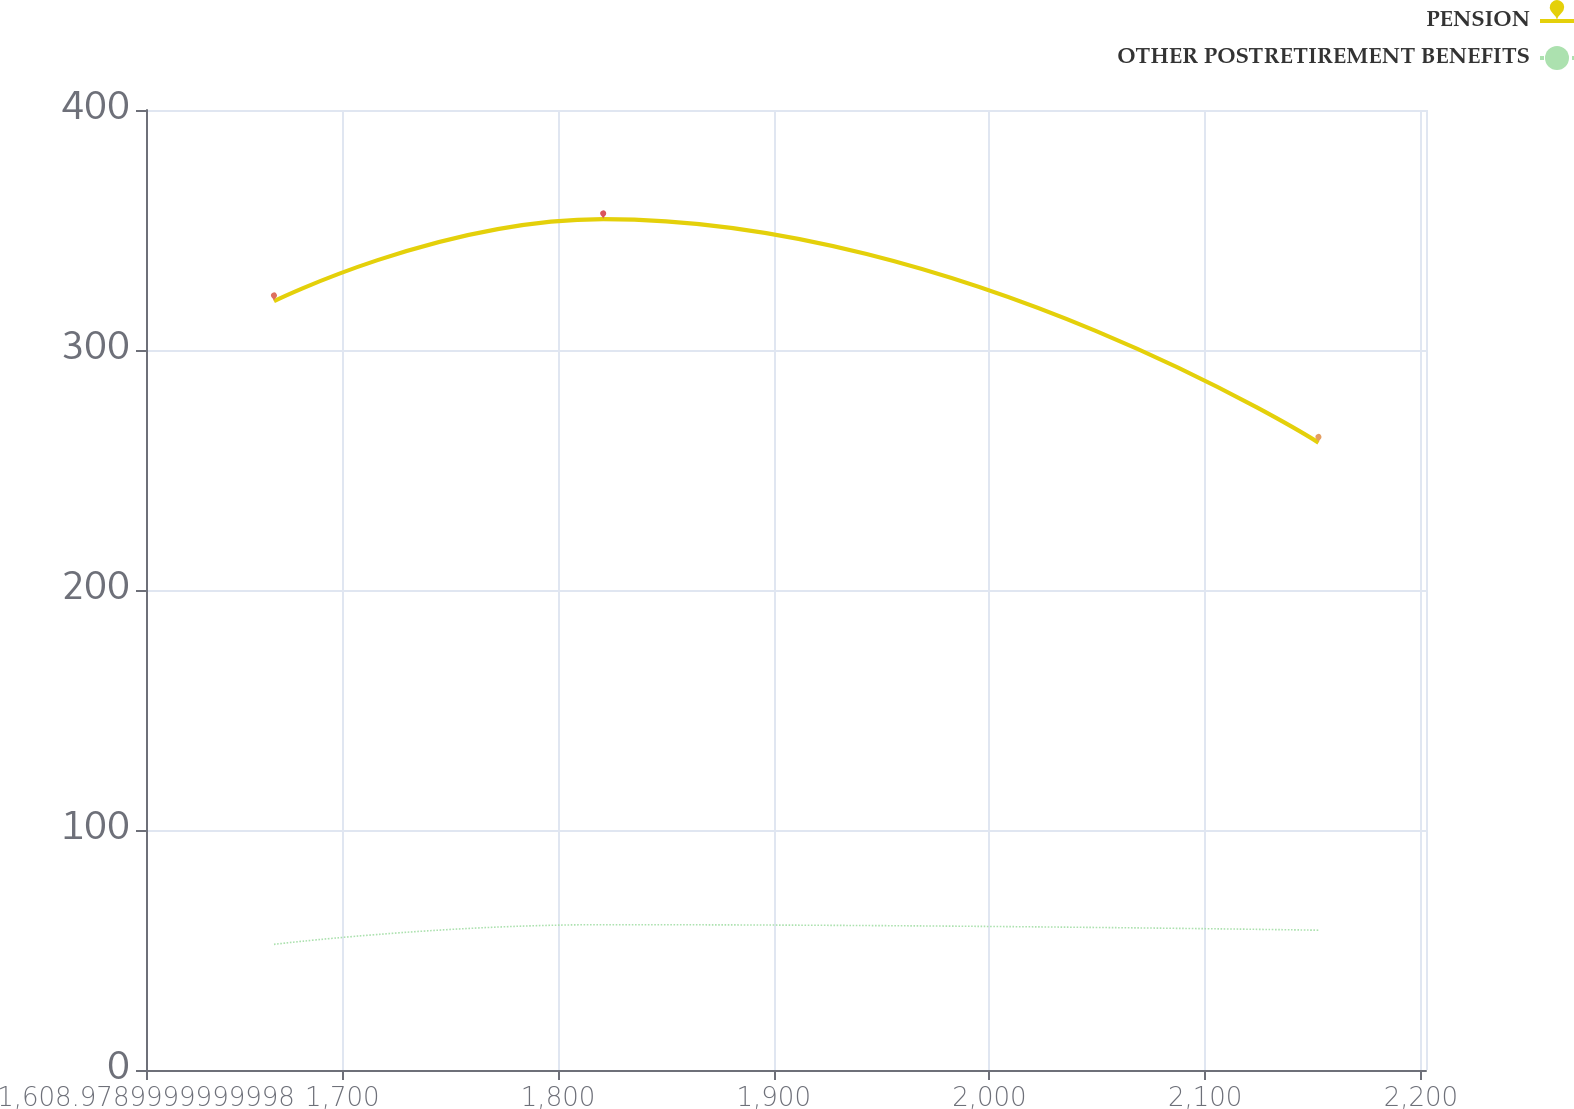<chart> <loc_0><loc_0><loc_500><loc_500><line_chart><ecel><fcel>PENSION<fcel>OTHER POSTRETIREMENT BENEFITS<nl><fcel>1668.32<fcel>320.34<fcel>52.36<nl><fcel>1820.95<fcel>354.56<fcel>60.55<nl><fcel>2152.55<fcel>261.4<fcel>58.25<nl><fcel>2207.14<fcel>364.2<fcel>61.7<nl><fcel>2261.73<fcel>344.92<fcel>62.72<nl></chart> 